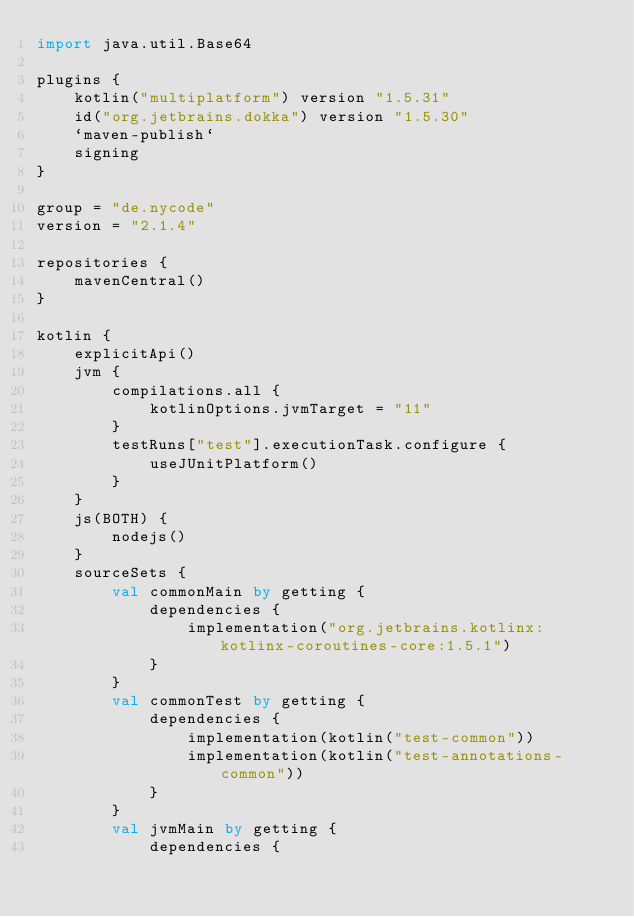Convert code to text. <code><loc_0><loc_0><loc_500><loc_500><_Kotlin_>import java.util.Base64

plugins {
    kotlin("multiplatform") version "1.5.31"
    id("org.jetbrains.dokka") version "1.5.30"
    `maven-publish`
    signing
}

group = "de.nycode"
version = "2.1.4"

repositories {
    mavenCentral()
}

kotlin {
    explicitApi()
    jvm {
        compilations.all {
            kotlinOptions.jvmTarget = "11"
        }
        testRuns["test"].executionTask.configure {
            useJUnitPlatform()
        }
    }
    js(BOTH) {
        nodejs()
    }
    sourceSets {
        val commonMain by getting {
            dependencies {
                implementation("org.jetbrains.kotlinx:kotlinx-coroutines-core:1.5.1")
            }
        }
        val commonTest by getting {
            dependencies {
                implementation(kotlin("test-common"))
                implementation(kotlin("test-annotations-common"))
            }
        }
        val jvmMain by getting {
            dependencies {</code> 